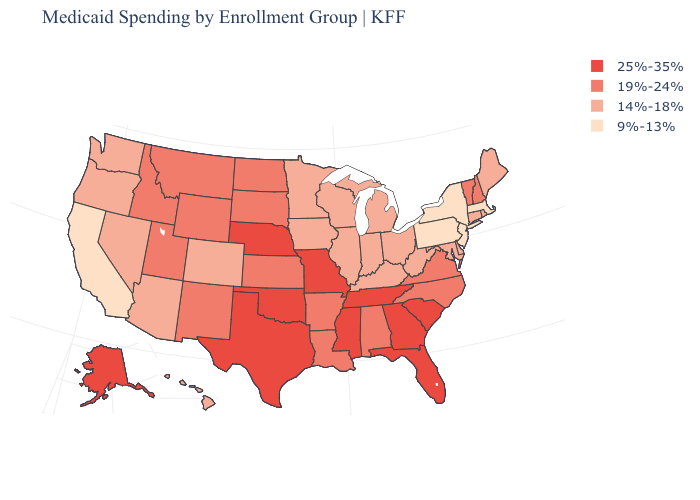What is the lowest value in states that border Rhode Island?
Be succinct. 9%-13%. Is the legend a continuous bar?
Short answer required. No. Name the states that have a value in the range 19%-24%?
Short answer required. Alabama, Arkansas, Idaho, Kansas, Louisiana, Montana, New Hampshire, New Mexico, North Carolina, North Dakota, South Dakota, Utah, Vermont, Virginia, Wyoming. Name the states that have a value in the range 14%-18%?
Concise answer only. Arizona, Colorado, Connecticut, Delaware, Hawaii, Illinois, Indiana, Iowa, Kentucky, Maine, Maryland, Michigan, Minnesota, Nevada, Ohio, Oregon, Rhode Island, Washington, West Virginia, Wisconsin. Among the states that border Indiana , which have the highest value?
Keep it brief. Illinois, Kentucky, Michigan, Ohio. Does New York have the lowest value in the USA?
Concise answer only. Yes. Among the states that border North Dakota , does South Dakota have the lowest value?
Be succinct. No. Name the states that have a value in the range 19%-24%?
Quick response, please. Alabama, Arkansas, Idaho, Kansas, Louisiana, Montana, New Hampshire, New Mexico, North Carolina, North Dakota, South Dakota, Utah, Vermont, Virginia, Wyoming. What is the highest value in the West ?
Write a very short answer. 25%-35%. Name the states that have a value in the range 9%-13%?
Write a very short answer. California, Massachusetts, New Jersey, New York, Pennsylvania. What is the value of Wisconsin?
Concise answer only. 14%-18%. What is the value of Utah?
Give a very brief answer. 19%-24%. How many symbols are there in the legend?
Short answer required. 4. Among the states that border Delaware , does Pennsylvania have the lowest value?
Answer briefly. Yes. What is the lowest value in the MidWest?
Short answer required. 14%-18%. 